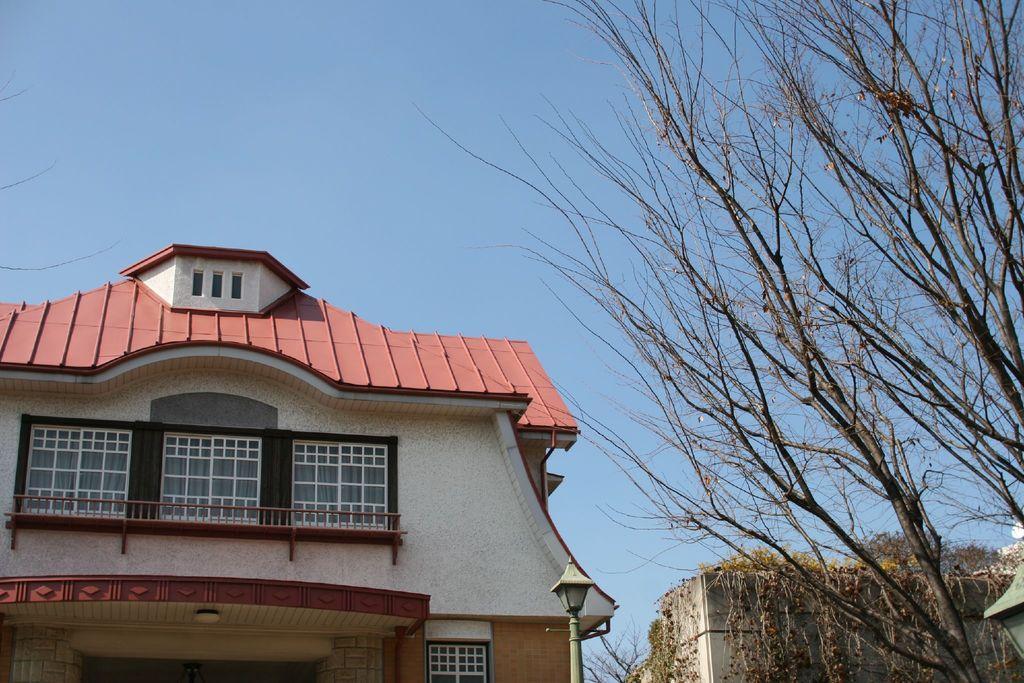Please provide a concise description of this image. In this picture we can see a building with windows, pole, trees and in the background we can see the sky. 